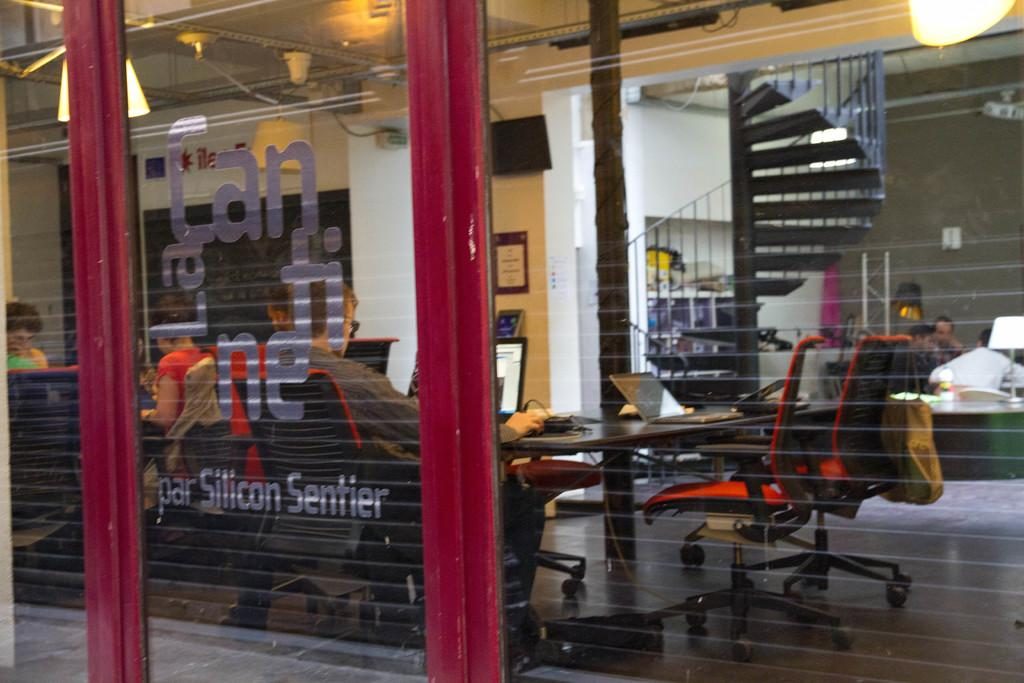<image>
Give a short and clear explanation of the subsequent image. outside a buliding with Par Silicon Sentier on the window 